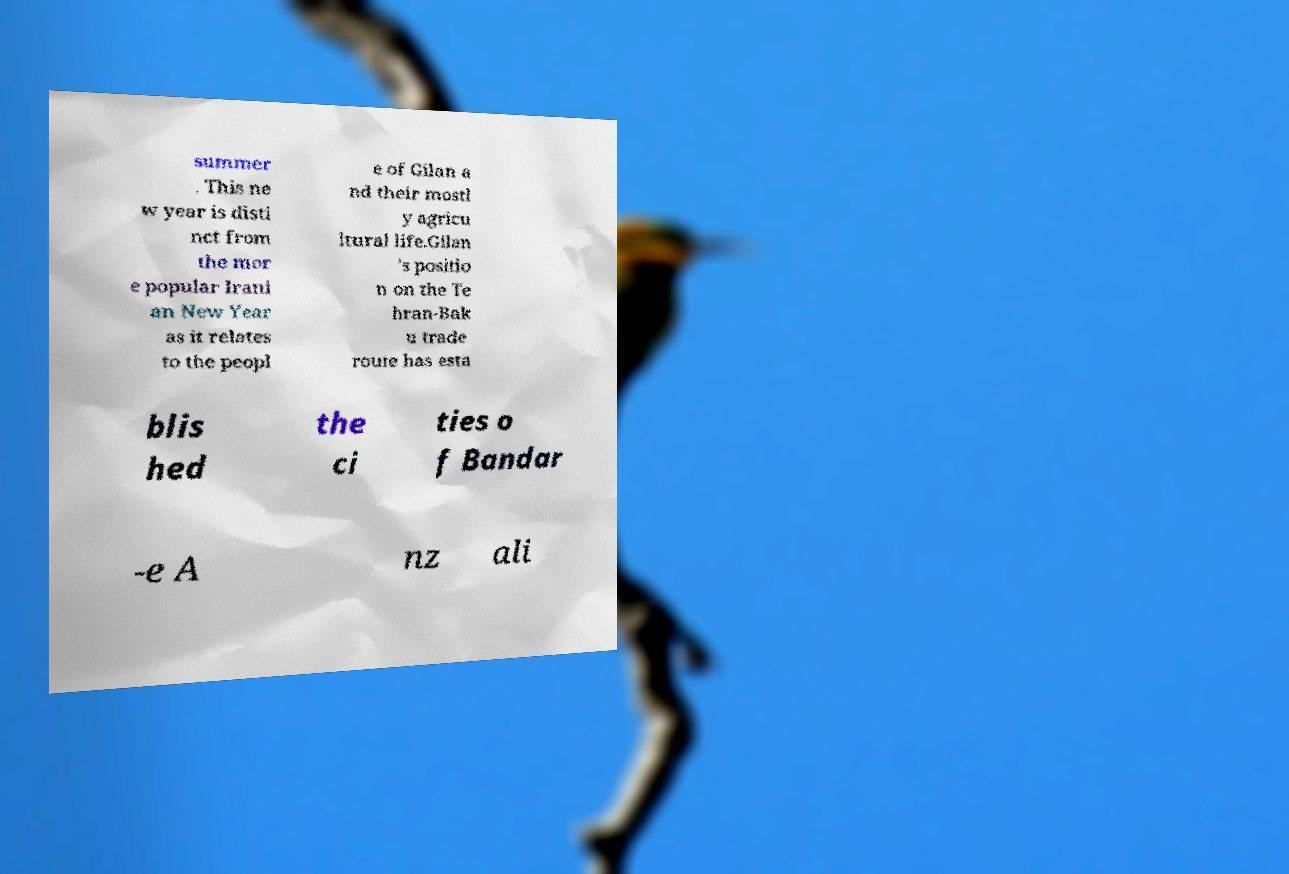Can you accurately transcribe the text from the provided image for me? summer . This ne w year is disti nct from the mor e popular Irani an New Year as it relates to the peopl e of Gilan a nd their mostl y agricu ltural life.Gilan 's positio n on the Te hran-Bak u trade route has esta blis hed the ci ties o f Bandar -e A nz ali 